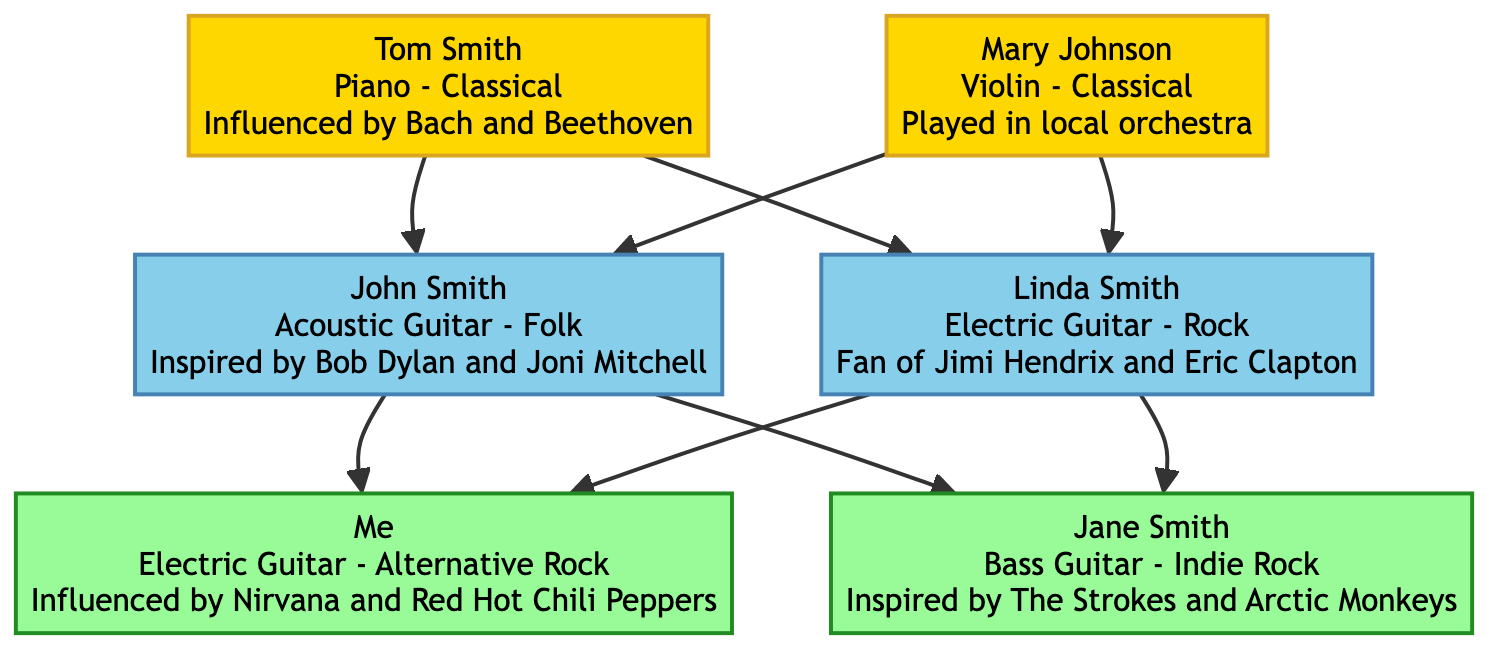What instruments did Tom Smith and Mary Johnson play? Tom Smith played the Piano, and Mary Johnson played the Violin. Both names are directly connected to their respective instruments in the diagram.
Answer: Piano, Violin How many total members are there in the family tree? There are 6 members in total: Tom Smith, Mary Johnson, John Smith, Linda Smith, Me, and Jane Smith. Each member is clearly represented in the diagram, and counting them yields 6.
Answer: 6 Who is influenced by Nirvana? I (Me) am influenced by Nirvana. This is indicated directly in the diagram, where "Me" is shown to have an influence from Nirvana and Red Hot Chili Peppers.
Answer: Me Which genre is represented by Linda Smith? Linda Smith is associated with the Rock genre. The diagram specifies her as playing the Electric Guitar and categorizes her influence under Rock.
Answer: Rock Who influenced John Smith? John Smith is influenced by Bob Dylan and Joni Mitchell. The information about his influences is explicitly stated next to his name in the diagram.
Answer: Bob Dylan and Joni Mitchell Which generation does Jane Smith belong to? Jane Smith belongs to "My Generation." The diagram categorizes her directly under this generation title, linking her to the same level as "Me."
Answer: My Generation What is the relationship between Tom Smith and Linda Smith? Tom Smith is the grandfather of Linda Smith. The diagram shows Tom Smith connected as a parent to John Smith, who is the father of Linda Smith, making Tom a grandfather.
Answer: Grandfather Which two members are connected through the same parent? Me and Jane Smith are connected through the same parents, John Smith and Linda Smith. Both are children of the same parents illustrated in the diagram.
Answer: Me and Jane Smith How many musicians in the family are associated with the Classical genre? There are 2 musicians associated with the Classical genre: Tom Smith and Mary Johnson. Each member's genre is clearly indicated in the diagram; counting them shows 2.
Answer: 2 